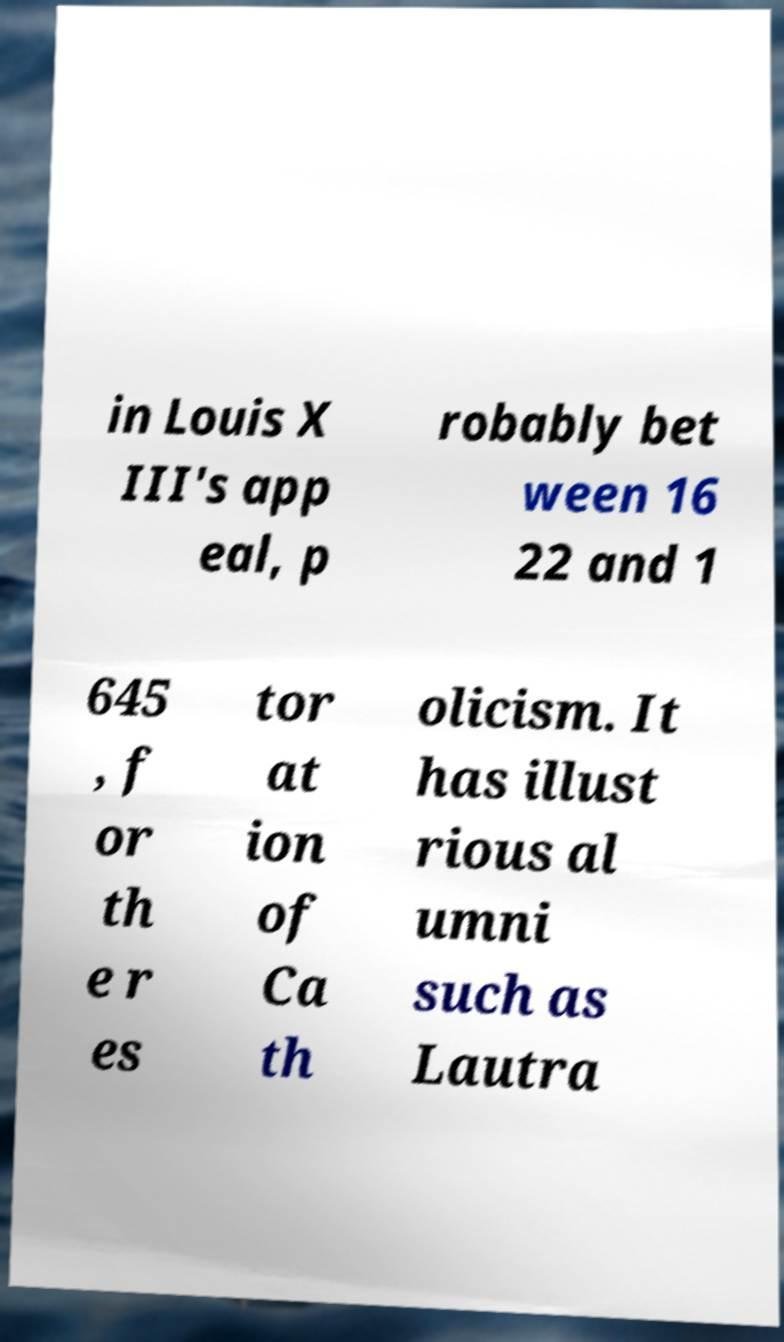Could you assist in decoding the text presented in this image and type it out clearly? in Louis X III's app eal, p robably bet ween 16 22 and 1 645 , f or th e r es tor at ion of Ca th olicism. It has illust rious al umni such as Lautra 